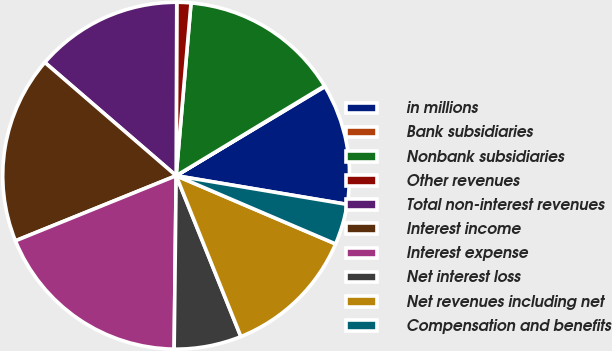Convert chart. <chart><loc_0><loc_0><loc_500><loc_500><pie_chart><fcel>in millions<fcel>Bank subsidiaries<fcel>Nonbank subsidiaries<fcel>Other revenues<fcel>Total non-interest revenues<fcel>Interest income<fcel>Interest expense<fcel>Net interest loss<fcel>Net revenues including net<fcel>Compensation and benefits<nl><fcel>11.24%<fcel>0.07%<fcel>14.97%<fcel>1.31%<fcel>13.73%<fcel>17.45%<fcel>18.69%<fcel>6.27%<fcel>12.48%<fcel>3.79%<nl></chart> 